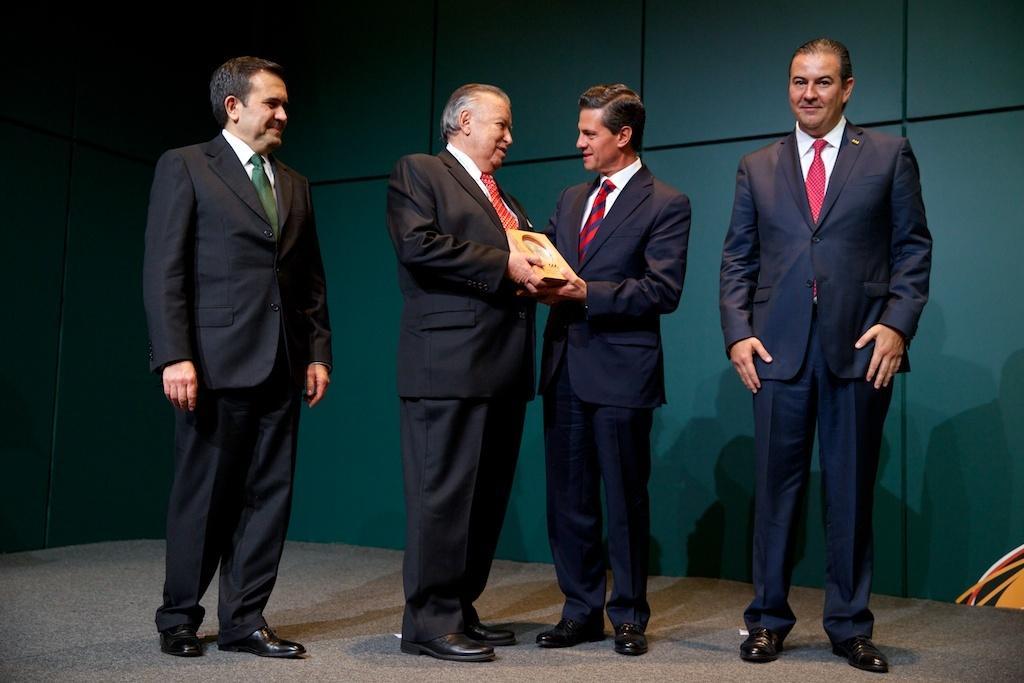Can you describe this image briefly? In this image, we can see there are four persons in suits, smiling and standing on a stage. Two of them are holding an object. In the background, there is a green color wall. 